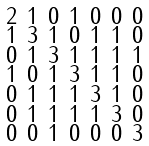Convert formula to latex. <formula><loc_0><loc_0><loc_500><loc_500>\begin{smallmatrix} 2 & 1 & 0 & 1 & 0 & 0 & 0 \\ 1 & 3 & 1 & 0 & 1 & 1 & 0 \\ 0 & 1 & 3 & 1 & 1 & 1 & 1 \\ 1 & 0 & 1 & 3 & 1 & 1 & 0 \\ 0 & 1 & 1 & 1 & 3 & 1 & 0 \\ 0 & 1 & 1 & 1 & 1 & 3 & 0 \\ 0 & 0 & 1 & 0 & 0 & 0 & 3 \end{smallmatrix}</formula> 